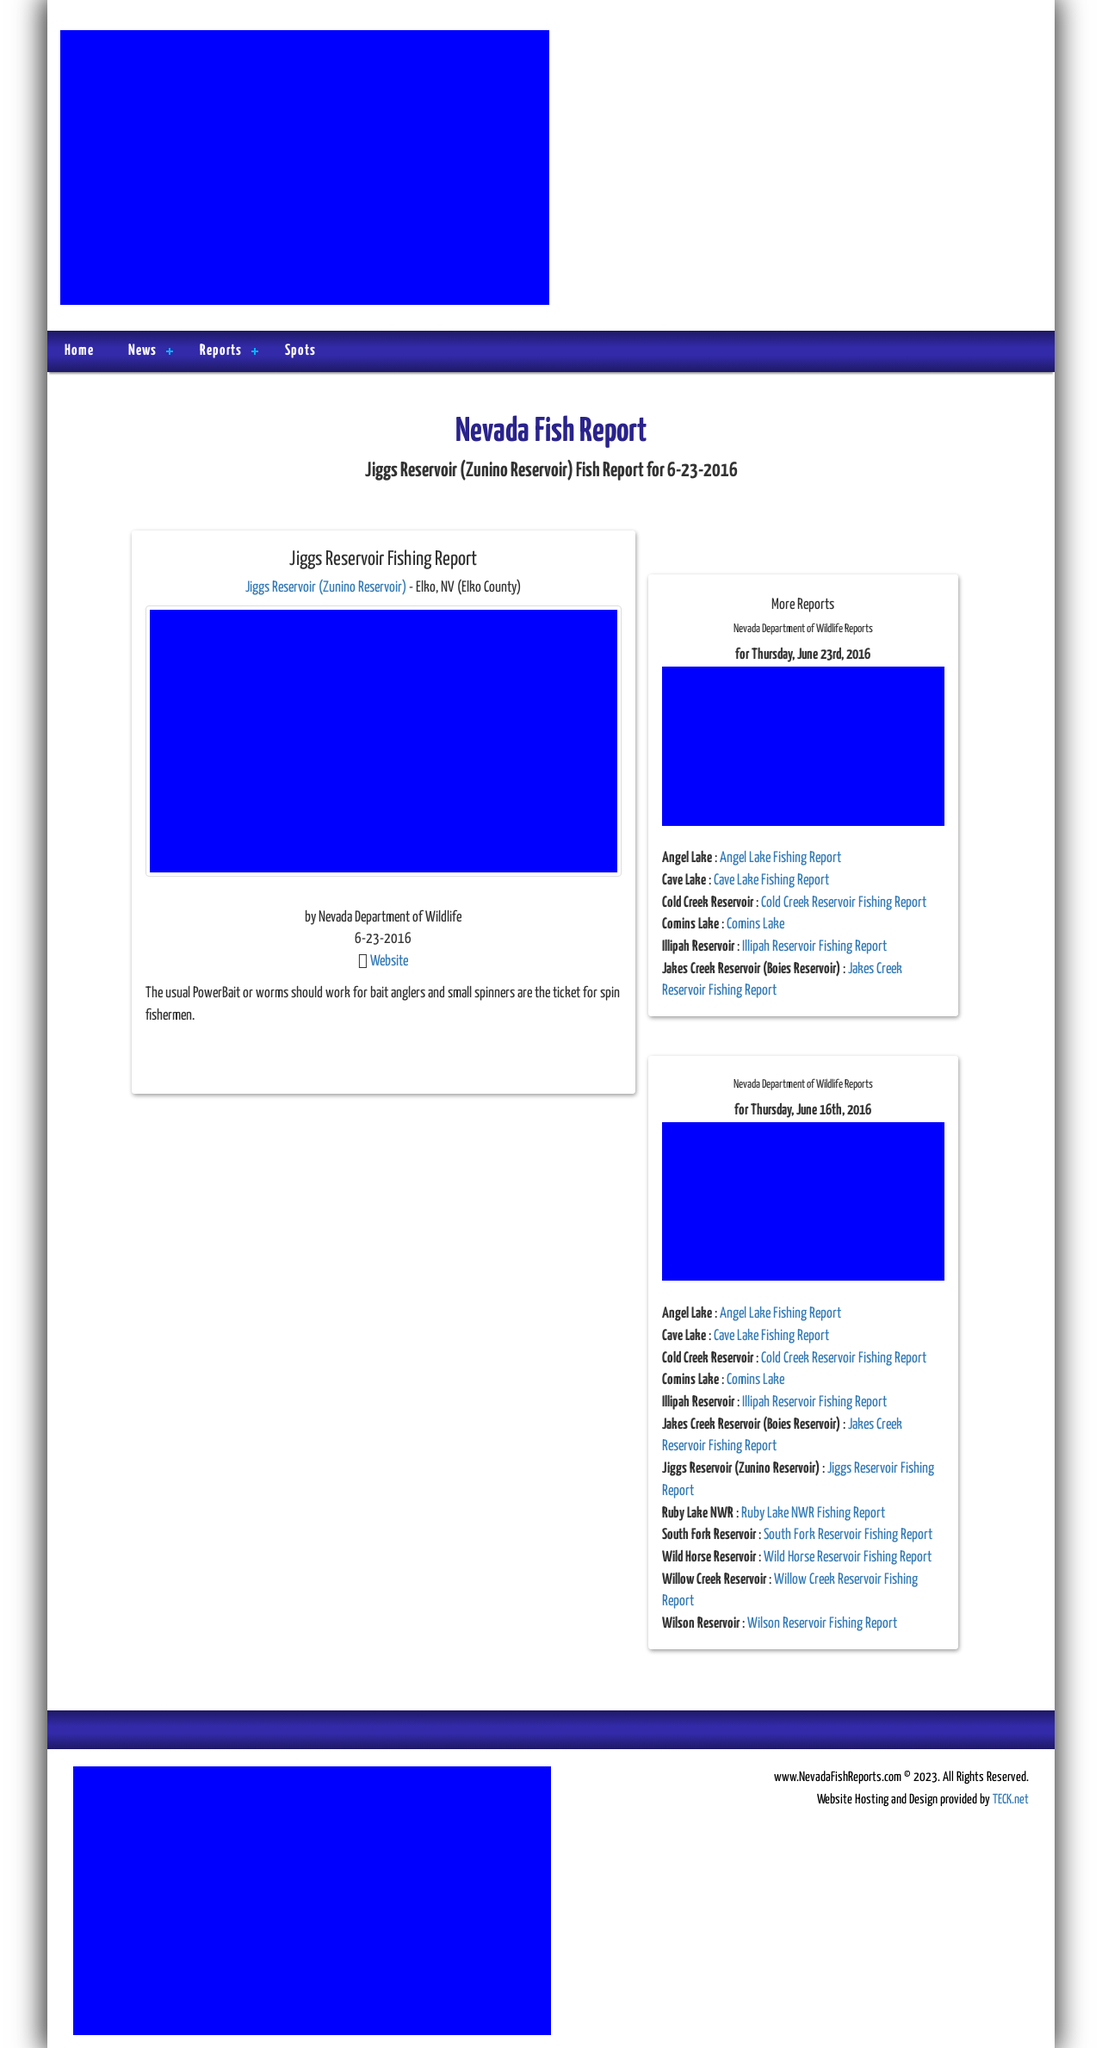Can you tell me more about the fishing conditions and popular spots mentioned in this website? The website appears to offer detailed fishing reports for various locations, notably Jiggs Reservoir in Elko, NV. This reservoir is mentioned to favor baits like PowerBait or worms, with techniques such as using small spinners being effective for spin fishermen. Aside from Jiggs, other hotspots listed include Angel Lake, Cave Lake, and other local bodies of water each equipped with their own specific fishing recommendations and conditions. 